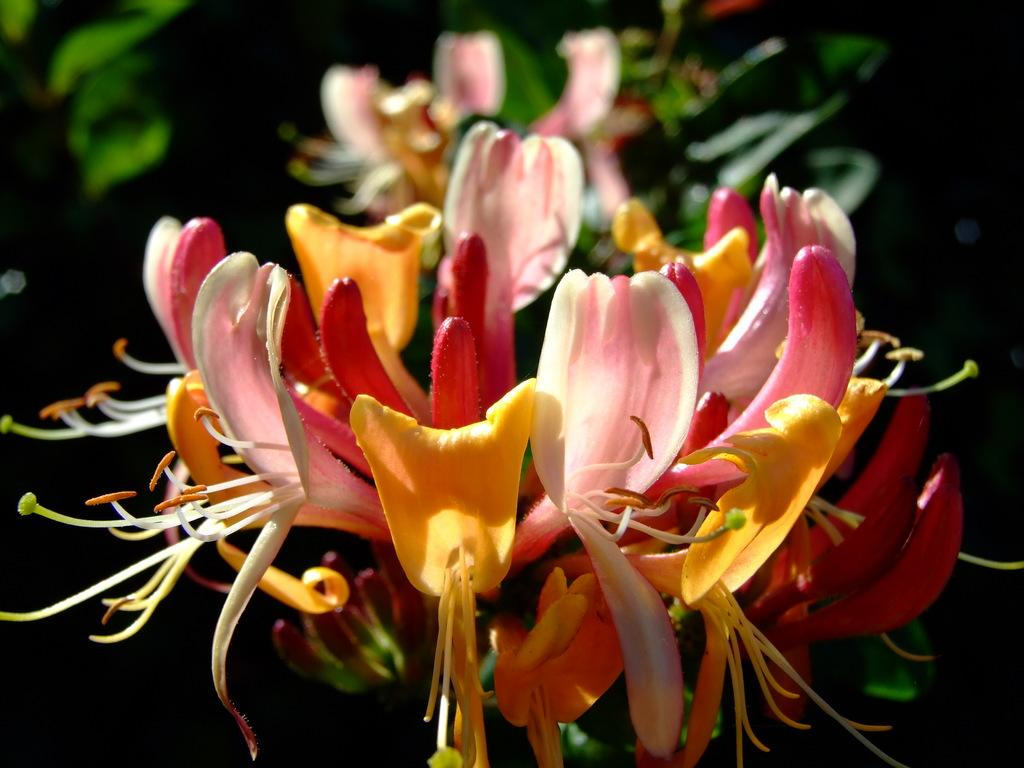What type of living organisms can be seen in the image? Flowers can be seen in the image. What type of unit is being protested in the image? There is no protest or unit present in the image; it only features flowers. 